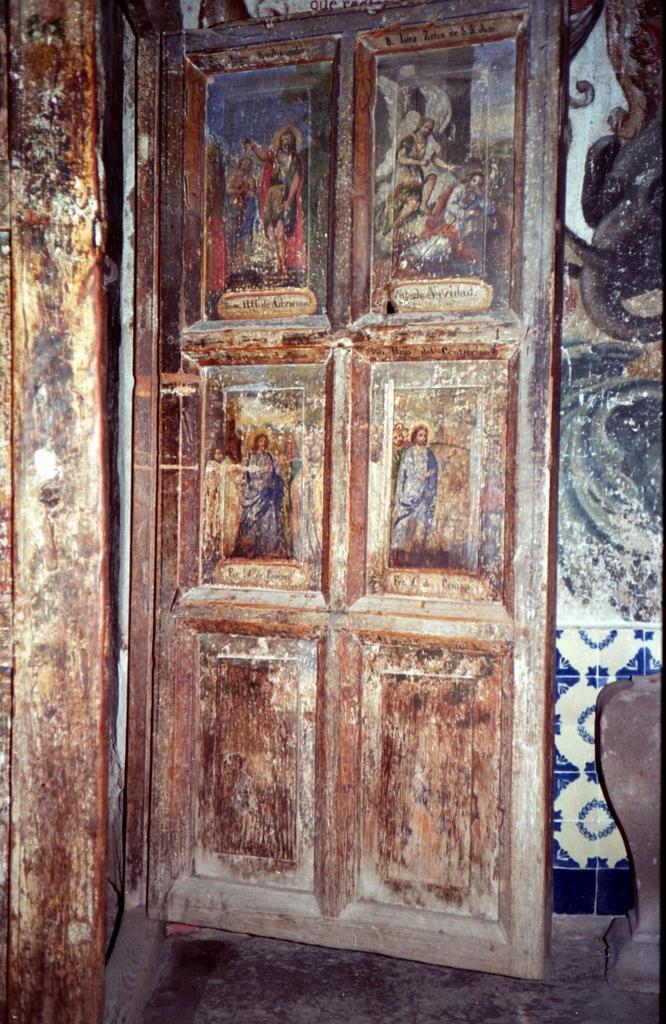In one or two sentences, can you explain what this image depicts? In this image there is a door and wall. Pictures are on the door. 